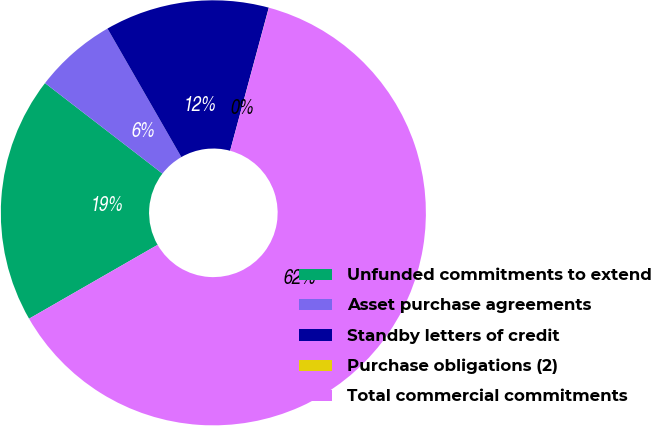<chart> <loc_0><loc_0><loc_500><loc_500><pie_chart><fcel>Unfunded commitments to extend<fcel>Asset purchase agreements<fcel>Standby letters of credit<fcel>Purchase obligations (2)<fcel>Total commercial commitments<nl><fcel>18.75%<fcel>6.25%<fcel>12.5%<fcel>0.01%<fcel>62.49%<nl></chart> 